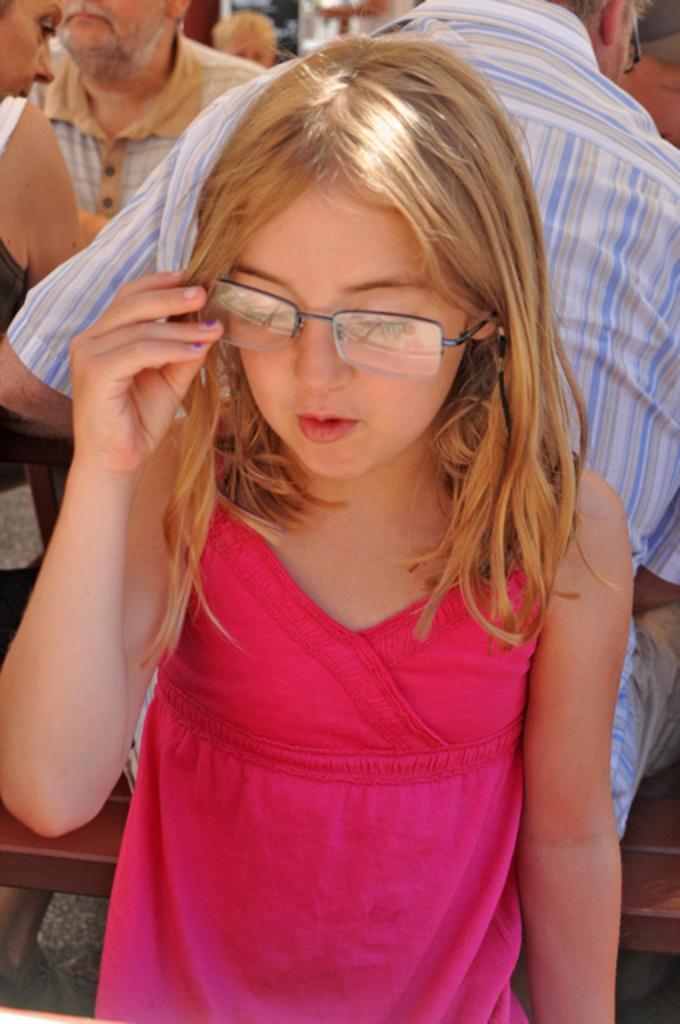Please provide a concise description of this image. This image is taken indoors. In the middle of the image a girl is standing and she has worn a spectacle. In the background a few people are sitting on the benches. 